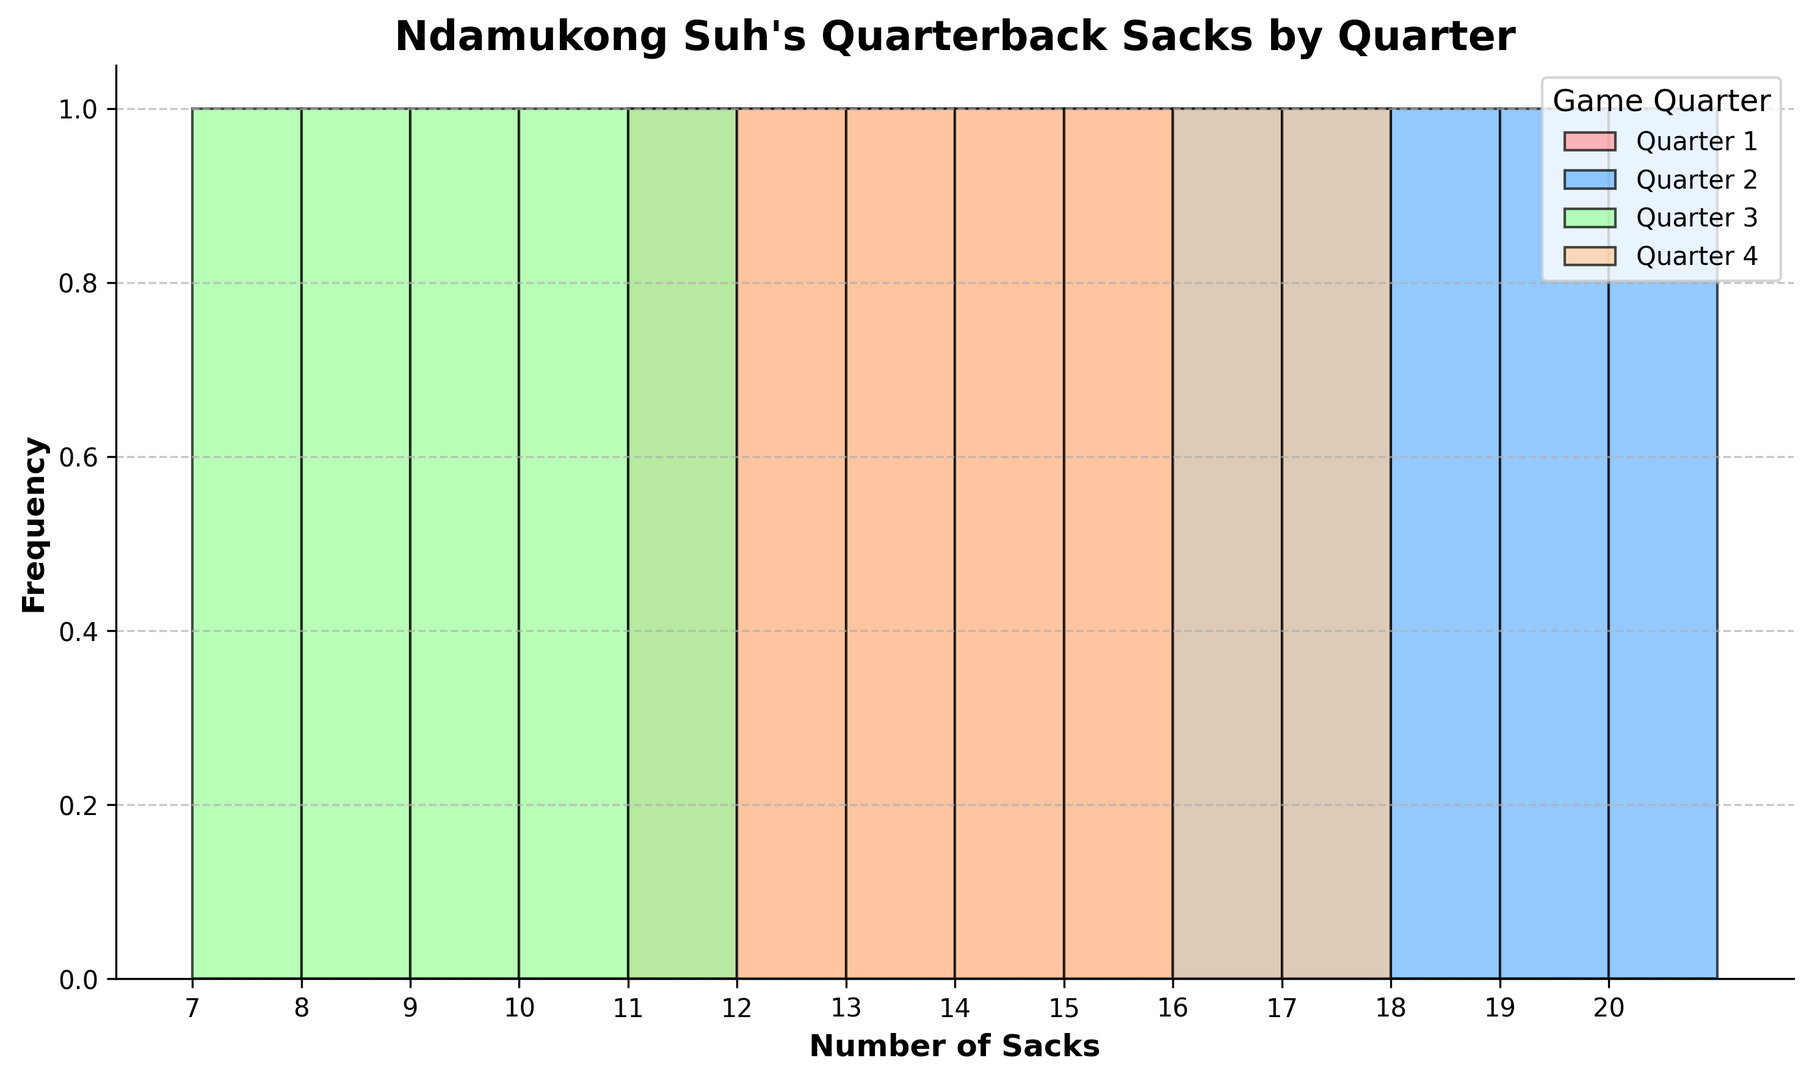How many total sacks were recorded in the 2nd quarter? First, count the number of bars representing the 2nd quarter. There are 5 bars. Sum the values at each bar (18 + 20 + 17 + 19 + 16) to get the total number of sacks.
Answer: 90 Which quarter has the highest frequency of sacks between 10 and 15? Identify the quarters associated with each color and count the bars between 10-15 sacks. The 2nd quarter has 0 bars, the 1st quarter has 5 bars, the 3rd quarter has 0 bars, and the 4th quarter has 4 bars. Therefore, the 1st quarter has the highest frequency in this range.
Answer: 1st In which quarter did Suh achieve the fewest recorded sacks? Look at the total height of the bars for each quarter. Identify the quarter with the smallest total bar heights. The 3rd quarter has the fewest since all its bars are comparatively shorter.
Answer: 3rd What is the range of sacks recorded in the 4th quarter? The range is calculated by taking the difference between the maximum and minimum values. The sacks in the 4th quarter range from 12 to 17. So, 17 - 12 = 5.
Answer: 5 Which quarter exhibits the most variability in the number of sacks? Variability can be assessed by visually comparing the spread of the bars. The 2nd quarter has sacks ranging from 16 to 20, making it narrow, while the 3rd quarter ranges from 7 to 11, making it less variable. The 1st and 4th quarters show similar wide ranges, but the 4th quarter extends to a higher sack count.
Answer: 4th What is the most common number of sacks recorded in the 1st quarter? Identify the bar with the highest frequency within the 1st quarter group (red bars). The bar at 12 sacks seems to be the most common.
Answer: 12 Are there any quarters where more than 15 sacks were frequently recorded? Observe the plotted bars to see where the counts exceed 15 sacks. Only the 2nd quarter (blue bars) consistently records more than 15 sacks.
Answer: 2nd What is the combined total range of sacks for all quarters? Combine the ranges of all quarters. The minimum count is 7 sacks from the 3rd quarter, and the maximum count is 20 sacks from the 2nd quarter. So, 20 - 7 = 13.
Answer: 13 